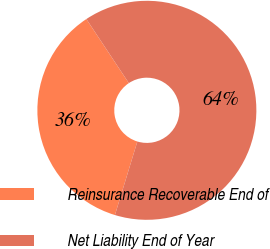<chart> <loc_0><loc_0><loc_500><loc_500><pie_chart><fcel>Reinsurance Recoverable End of<fcel>Net Liability End of Year<nl><fcel>35.97%<fcel>64.03%<nl></chart> 